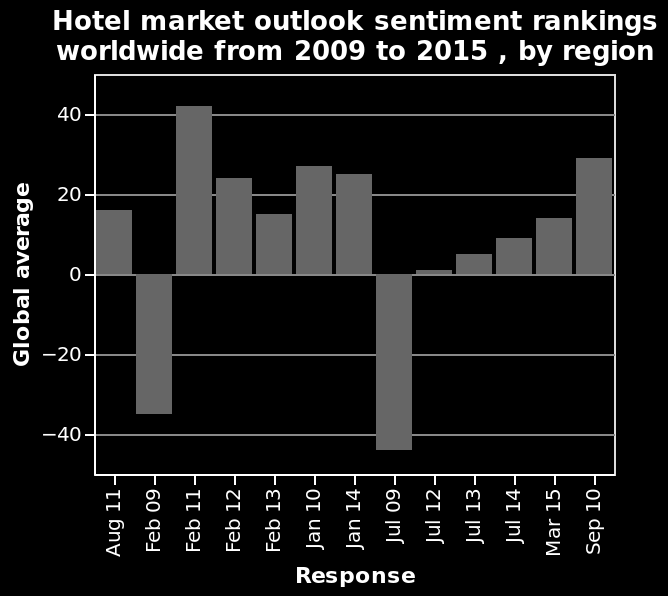<image>
What is the timeframe of the hotel market outlook sentiment rankings worldwide data? The timeframe of the hotel market outlook sentiment rankings worldwide data is from 2009 to 2015. In which year did the global averages reach their lowest point? The global averages reached their lowest point in 2009. What does the y-axis of the bar diagram measure? The y-axis of the bar diagram measures Global average with categorical scale from −40 to 40. 